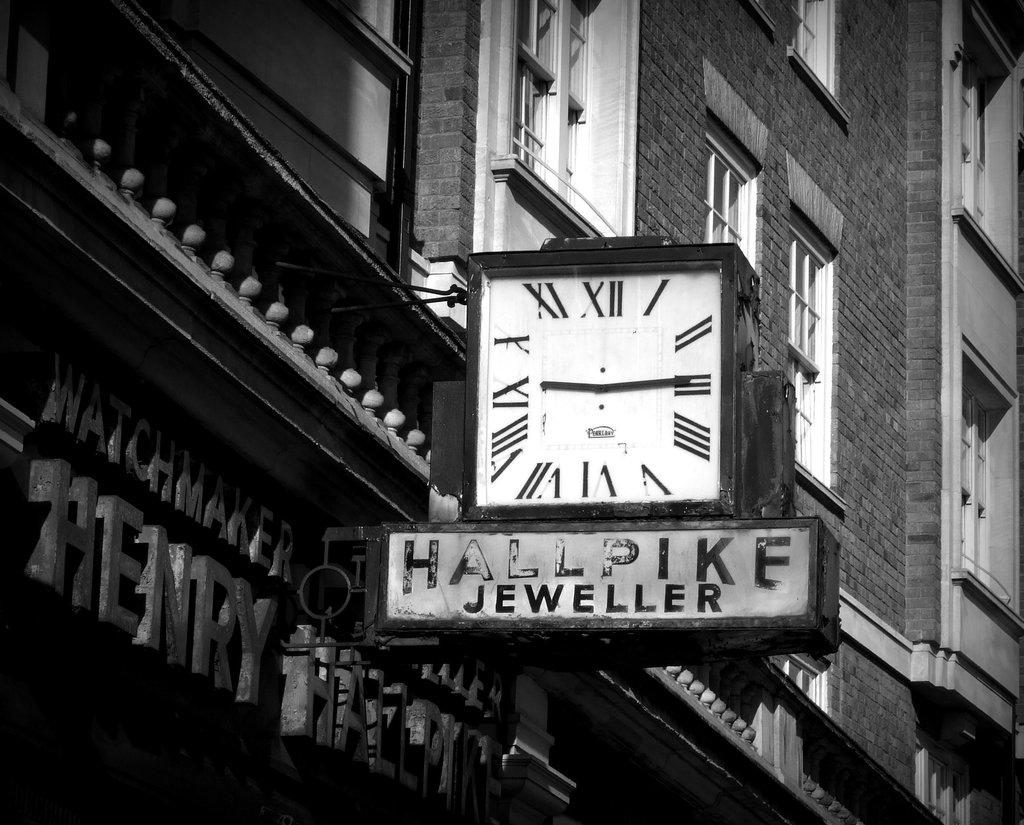<image>
Describe the image concisely. Store front with a clock and the sign saying Hallpike Jeweller. 